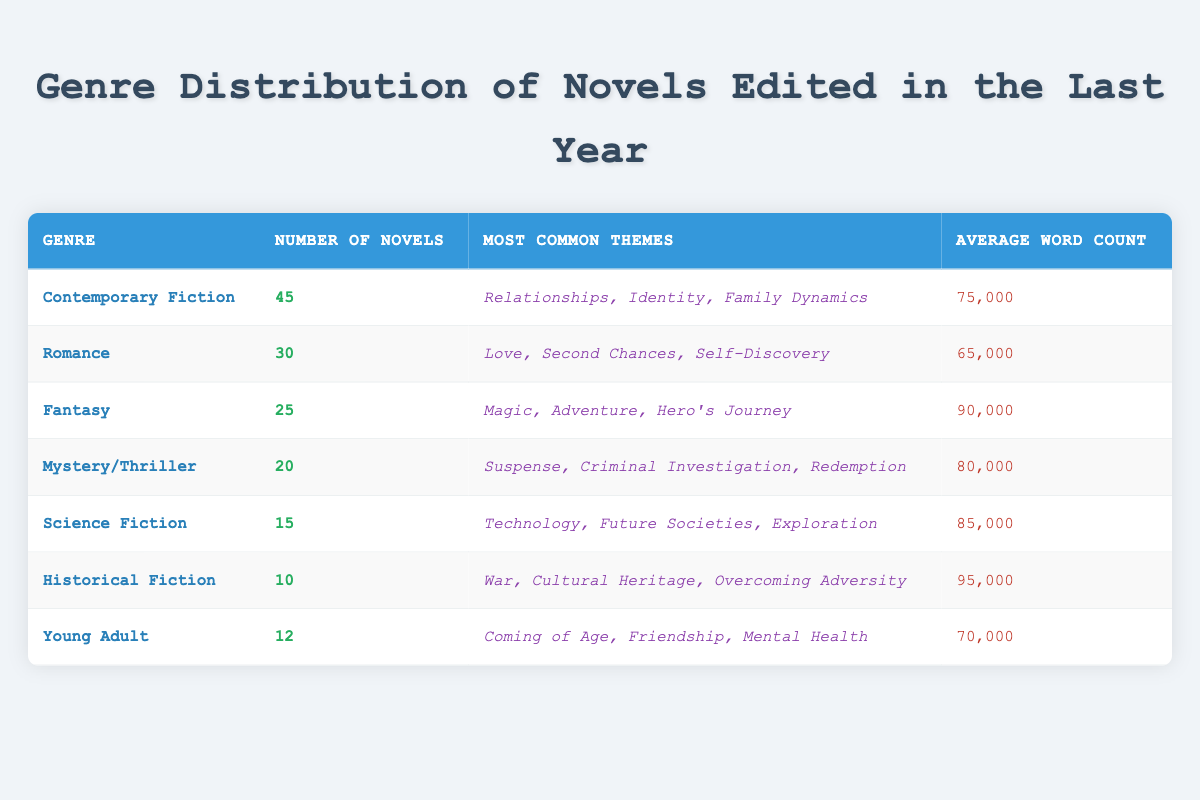What is the genre with the highest number of novels edited? The table lists the genres and their corresponding number of novels. "Contemporary Fiction" has the highest count at 45 novels.
Answer: Contemporary Fiction How many novels are in the Romance genre? The number of novels in the Romance genre is specified directly in the table as 30.
Answer: 30 What is the average word count for Fantasy novels? The table indicates that the average word count for Fantasy novels is 90,000 words.
Answer: 90,000 Which genres have the most common themes including "Adventure"? By examining the themes listed in the table, "Fantasy" is the only genre that includes "Adventure" as one of its most common themes.
Answer: Fantasy If we consider "Historical Fiction" and "Young Adult," how many novels in total were edited in these genres? Adding the number of novels in both genres: Historical Fiction has 10 novels and Young Adult has 12 novels, totaling 10 + 12 = 22 novels.
Answer: 22 Is the average word count for "Science Fiction" higher than 80,000 words? The average word count for Science Fiction is 85,000 words, which is higher than 80,000.
Answer: Yes What is the most common theme in the Mystery/Thriller genre? The table identifies "Suspense" as one of the most common themes for the Mystery/Thriller genre.
Answer: Suspense How many more novels are there in the Contemporary Fiction genre compared to Mystery/Thriller? The number of novels in Contemporary Fiction is 45 and in Mystery/Thriller is 20. The difference is 45 - 20 = 25.
Answer: 25 Is the average word count for Romance novels less than the average word count for Young Adult novels? The average word count for Romance is 65,000 words, while for Young Adult it is 70,000, thus Romance's average word count is less.
Answer: Yes 